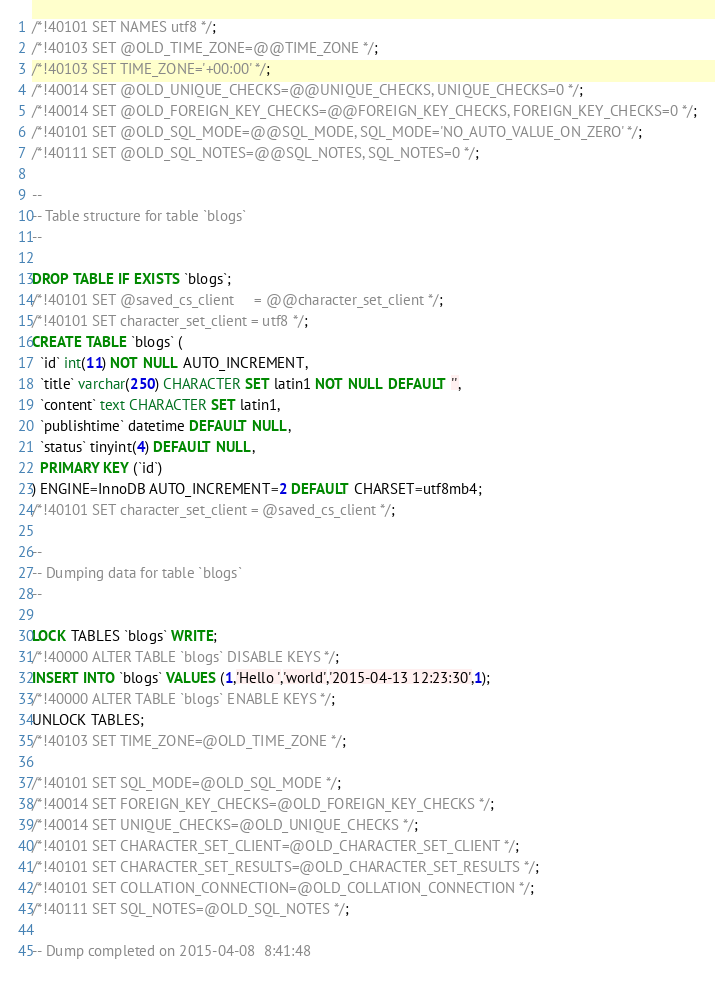<code> <loc_0><loc_0><loc_500><loc_500><_SQL_>/*!40101 SET NAMES utf8 */;
/*!40103 SET @OLD_TIME_ZONE=@@TIME_ZONE */;
/*!40103 SET TIME_ZONE='+00:00' */;
/*!40014 SET @OLD_UNIQUE_CHECKS=@@UNIQUE_CHECKS, UNIQUE_CHECKS=0 */;
/*!40014 SET @OLD_FOREIGN_KEY_CHECKS=@@FOREIGN_KEY_CHECKS, FOREIGN_KEY_CHECKS=0 */;
/*!40101 SET @OLD_SQL_MODE=@@SQL_MODE, SQL_MODE='NO_AUTO_VALUE_ON_ZERO' */;
/*!40111 SET @OLD_SQL_NOTES=@@SQL_NOTES, SQL_NOTES=0 */;

--
-- Table structure for table `blogs`
--

DROP TABLE IF EXISTS `blogs`;
/*!40101 SET @saved_cs_client     = @@character_set_client */;
/*!40101 SET character_set_client = utf8 */;
CREATE TABLE `blogs` (
  `id` int(11) NOT NULL AUTO_INCREMENT,
  `title` varchar(250) CHARACTER SET latin1 NOT NULL DEFAULT '',
  `content` text CHARACTER SET latin1,
  `publishtime` datetime DEFAULT NULL,
  `status` tinyint(4) DEFAULT NULL,
  PRIMARY KEY (`id`)
) ENGINE=InnoDB AUTO_INCREMENT=2 DEFAULT CHARSET=utf8mb4;
/*!40101 SET character_set_client = @saved_cs_client */;

--
-- Dumping data for table `blogs`
--

LOCK TABLES `blogs` WRITE;
/*!40000 ALTER TABLE `blogs` DISABLE KEYS */;
INSERT INTO `blogs` VALUES (1,'Hello ','world','2015-04-13 12:23:30',1);
/*!40000 ALTER TABLE `blogs` ENABLE KEYS */;
UNLOCK TABLES;
/*!40103 SET TIME_ZONE=@OLD_TIME_ZONE */;

/*!40101 SET SQL_MODE=@OLD_SQL_MODE */;
/*!40014 SET FOREIGN_KEY_CHECKS=@OLD_FOREIGN_KEY_CHECKS */;
/*!40014 SET UNIQUE_CHECKS=@OLD_UNIQUE_CHECKS */;
/*!40101 SET CHARACTER_SET_CLIENT=@OLD_CHARACTER_SET_CLIENT */;
/*!40101 SET CHARACTER_SET_RESULTS=@OLD_CHARACTER_SET_RESULTS */;
/*!40101 SET COLLATION_CONNECTION=@OLD_COLLATION_CONNECTION */;
/*!40111 SET SQL_NOTES=@OLD_SQL_NOTES */;

-- Dump completed on 2015-04-08  8:41:48
</code> 